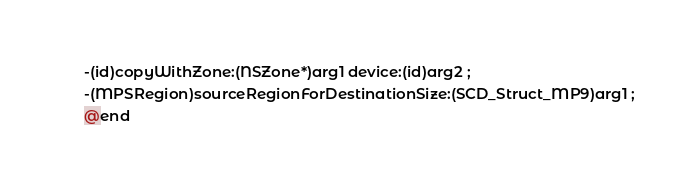Convert code to text. <code><loc_0><loc_0><loc_500><loc_500><_C_>-(id)copyWithZone:(NSZone*)arg1 device:(id)arg2 ;
-(MPSRegion)sourceRegionForDestinationSize:(SCD_Struct_MP9)arg1 ;
@end

</code> 